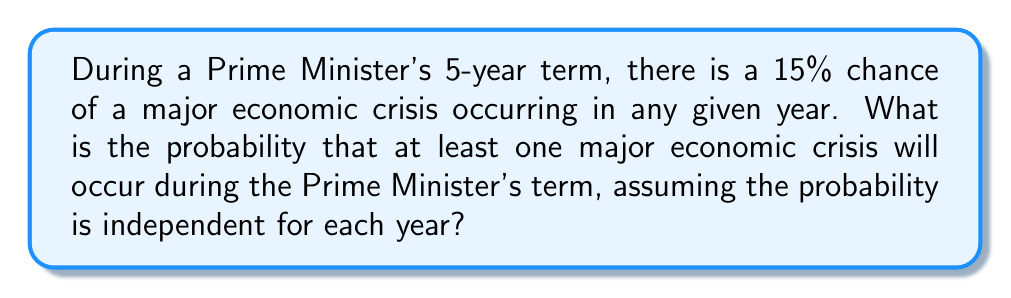Show me your answer to this math problem. Let's approach this step-by-step:

1) First, let's consider the probability that no major economic crisis occurs in a single year:
   $P(\text{no crisis in one year}) = 1 - 0.15 = 0.85$

2) For no crisis to occur over the 5-year term, we need this to happen for all 5 years independently. We can calculate this using the multiplication principle:
   $P(\text{no crisis in 5 years}) = 0.85^5 = 0.4437$

3) The question asks for the probability of at least one crisis occurring. This is the complement of the probability of no crisis occurring:
   $P(\text{at least one crisis in 5 years}) = 1 - P(\text{no crisis in 5 years})$

4) We can now calculate:
   $P(\text{at least one crisis in 5 years}) = 1 - 0.4437 = 0.5563$

5) To express this as a percentage:
   $0.5563 \times 100\% = 55.63\%$

This result suggests that there's a significant chance (more than 50%) of the Prime Minister facing at least one major economic crisis during their term, which could have substantial historical implications.
Answer: $55.63\%$ 